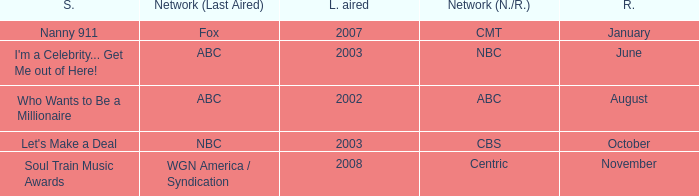What show was played on ABC laster after 2002? I'm a Celebrity... Get Me out of Here!. 